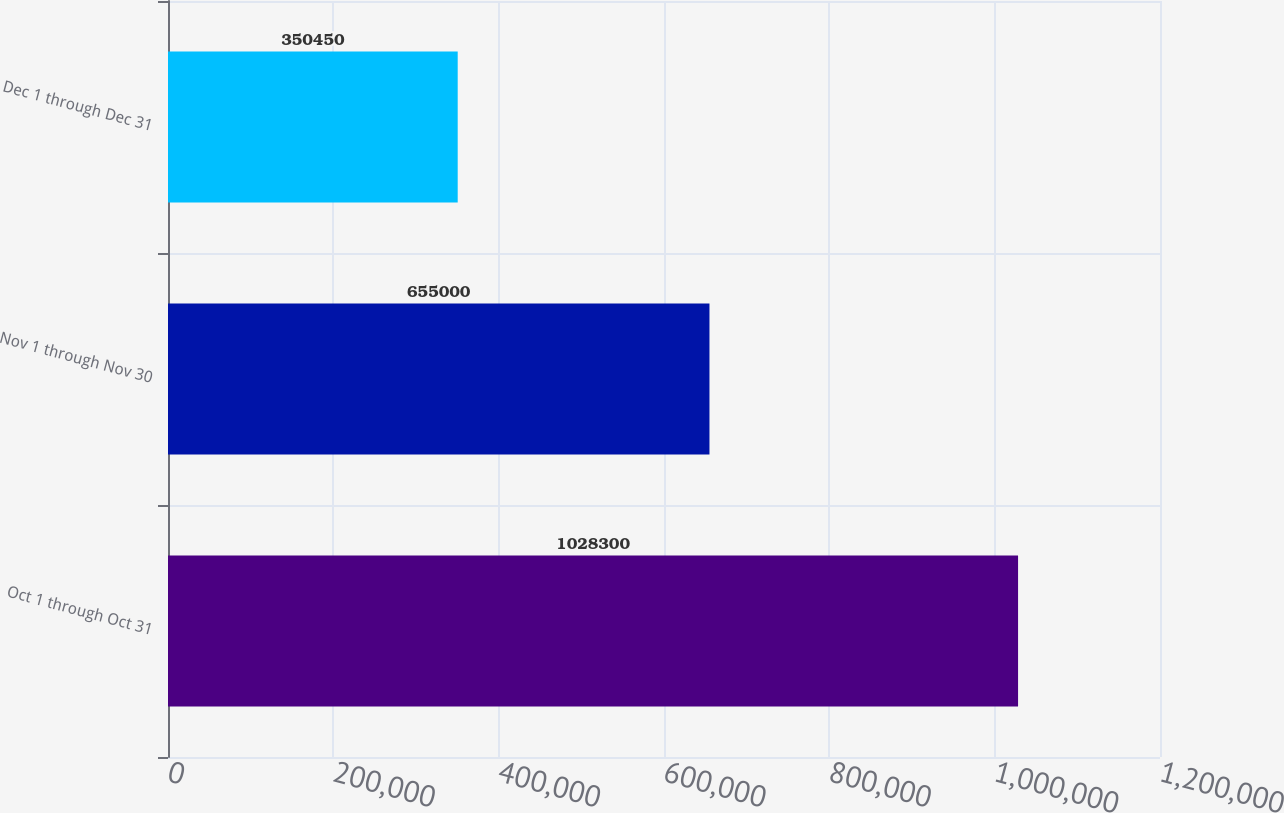<chart> <loc_0><loc_0><loc_500><loc_500><bar_chart><fcel>Oct 1 through Oct 31<fcel>Nov 1 through Nov 30<fcel>Dec 1 through Dec 31<nl><fcel>1.0283e+06<fcel>655000<fcel>350450<nl></chart> 